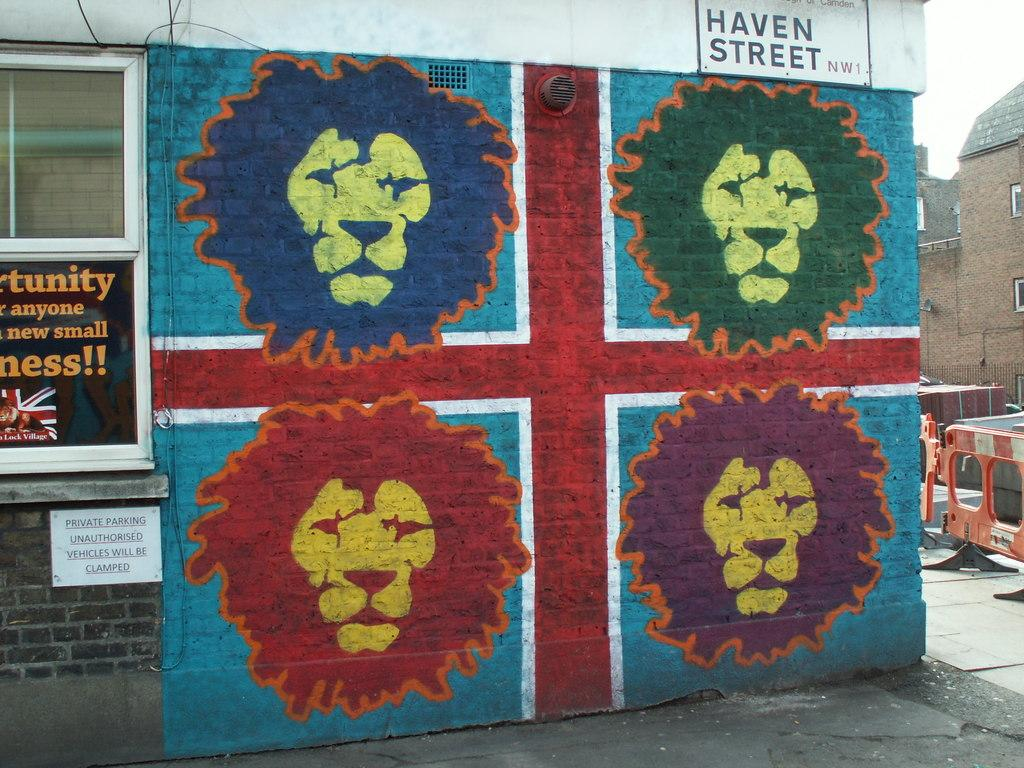<image>
Relay a brief, clear account of the picture shown. Four colorful lions painted on the side of a building on Haven Street. 